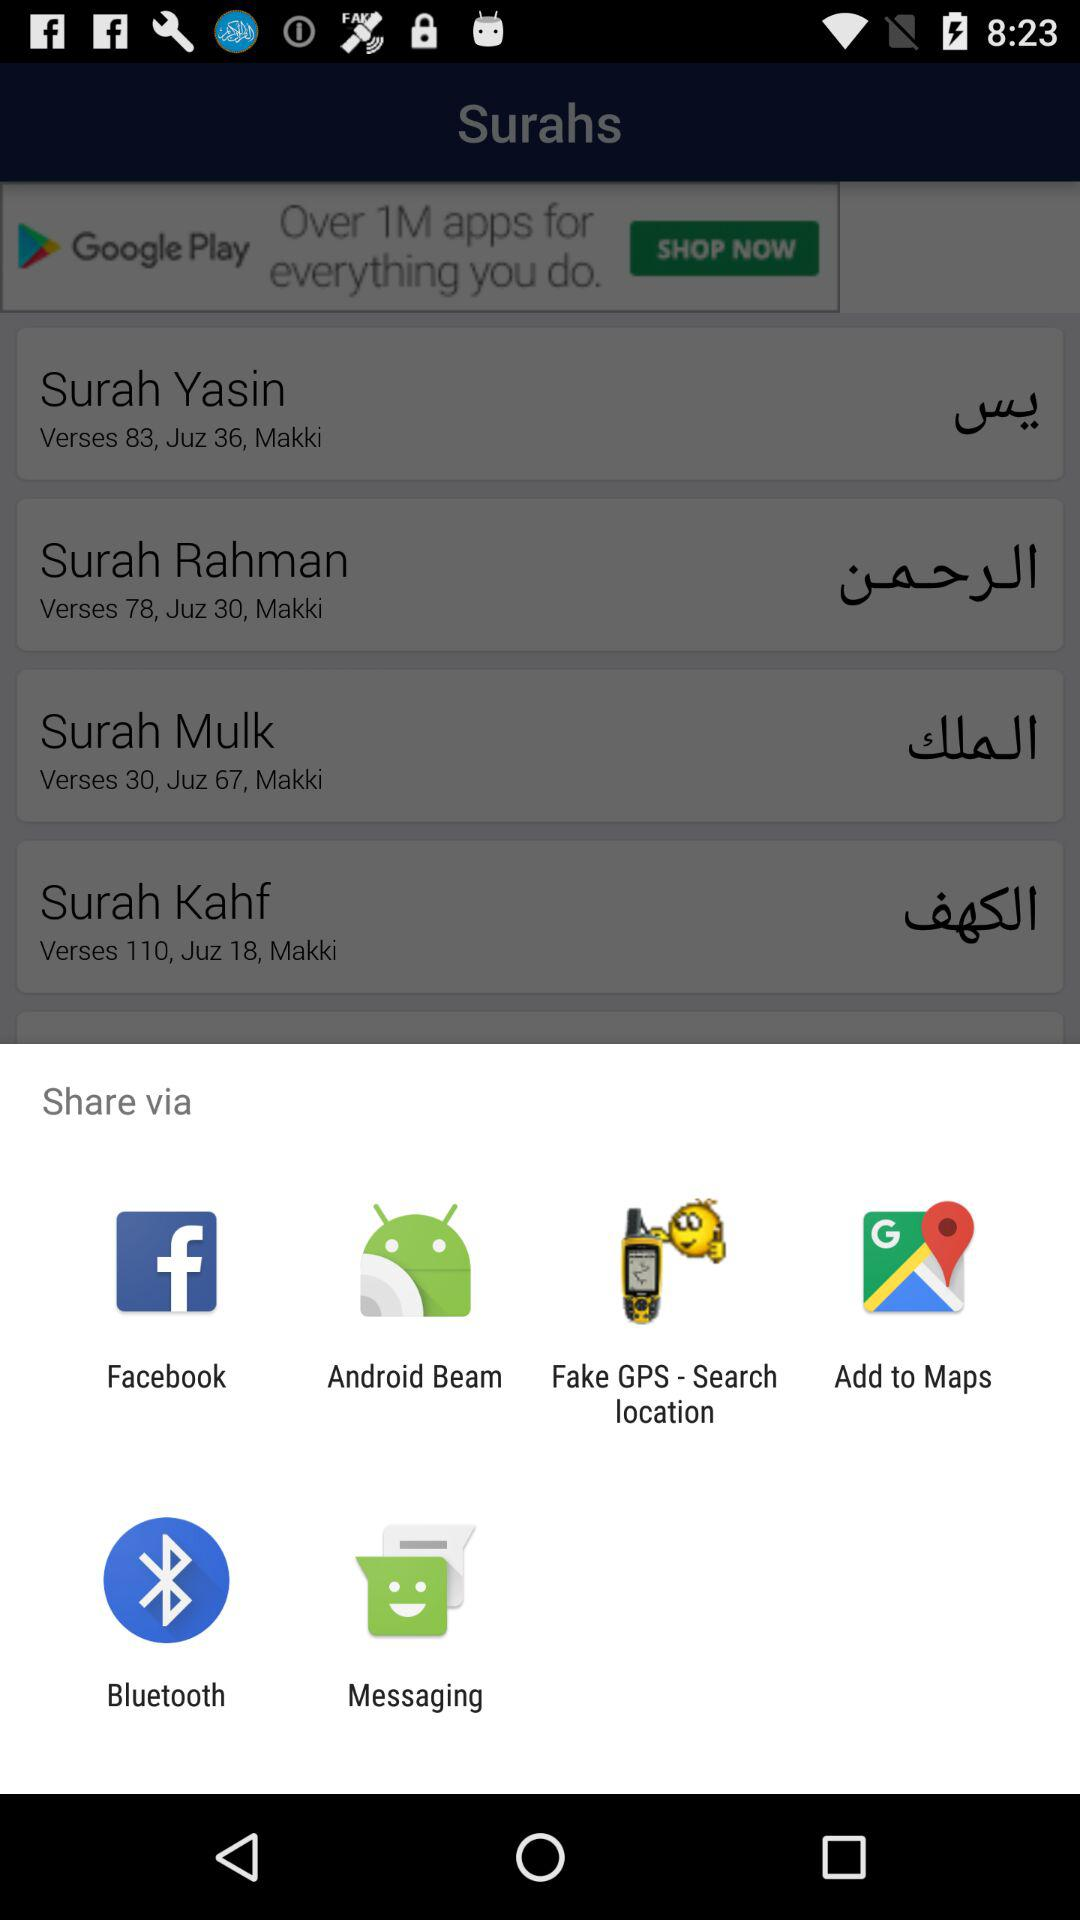How many of the share options are for social media?
Answer the question using a single word or phrase. 2 